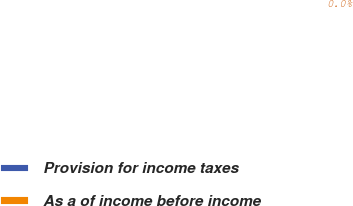Convert chart. <chart><loc_0><loc_0><loc_500><loc_500><pie_chart><fcel>Provision for income taxes<fcel>As a of income before income<nl><fcel>100.0%<fcel>0.0%<nl></chart> 